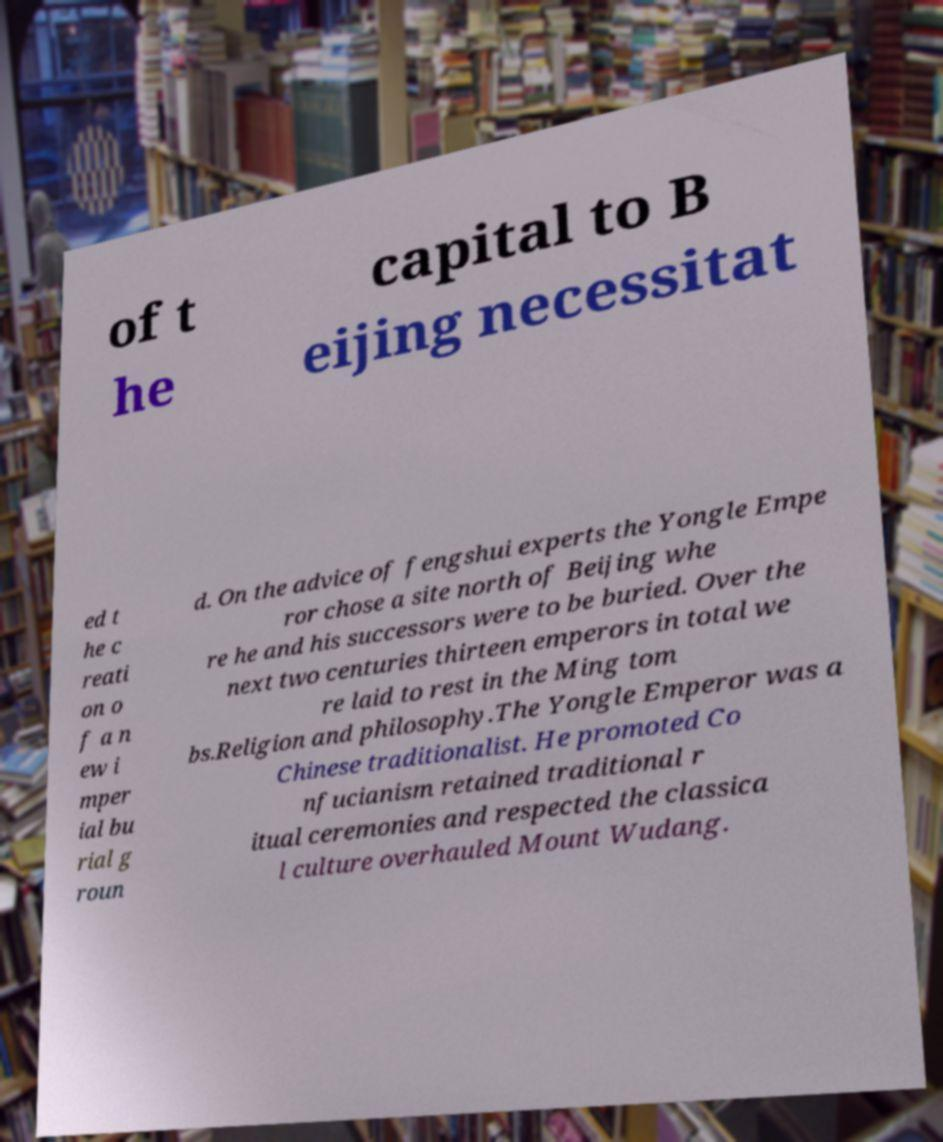Please identify and transcribe the text found in this image. of t he capital to B eijing necessitat ed t he c reati on o f a n ew i mper ial bu rial g roun d. On the advice of fengshui experts the Yongle Empe ror chose a site north of Beijing whe re he and his successors were to be buried. Over the next two centuries thirteen emperors in total we re laid to rest in the Ming tom bs.Religion and philosophy.The Yongle Emperor was a Chinese traditionalist. He promoted Co nfucianism retained traditional r itual ceremonies and respected the classica l culture overhauled Mount Wudang. 